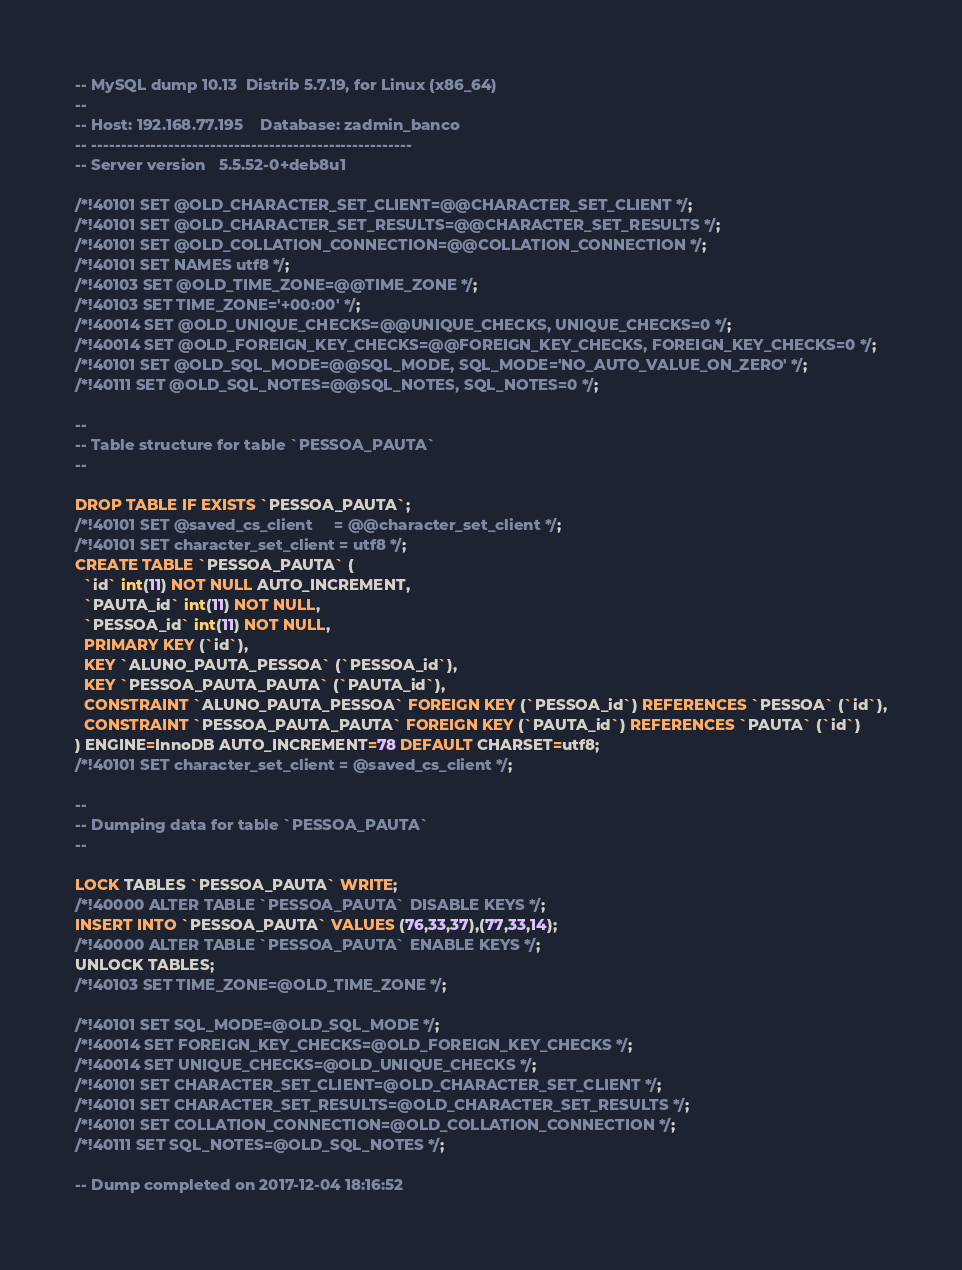Convert code to text. <code><loc_0><loc_0><loc_500><loc_500><_SQL_>-- MySQL dump 10.13  Distrib 5.7.19, for Linux (x86_64)
--
-- Host: 192.168.77.195    Database: zadmin_banco
-- ------------------------------------------------------
-- Server version	5.5.52-0+deb8u1

/*!40101 SET @OLD_CHARACTER_SET_CLIENT=@@CHARACTER_SET_CLIENT */;
/*!40101 SET @OLD_CHARACTER_SET_RESULTS=@@CHARACTER_SET_RESULTS */;
/*!40101 SET @OLD_COLLATION_CONNECTION=@@COLLATION_CONNECTION */;
/*!40101 SET NAMES utf8 */;
/*!40103 SET @OLD_TIME_ZONE=@@TIME_ZONE */;
/*!40103 SET TIME_ZONE='+00:00' */;
/*!40014 SET @OLD_UNIQUE_CHECKS=@@UNIQUE_CHECKS, UNIQUE_CHECKS=0 */;
/*!40014 SET @OLD_FOREIGN_KEY_CHECKS=@@FOREIGN_KEY_CHECKS, FOREIGN_KEY_CHECKS=0 */;
/*!40101 SET @OLD_SQL_MODE=@@SQL_MODE, SQL_MODE='NO_AUTO_VALUE_ON_ZERO' */;
/*!40111 SET @OLD_SQL_NOTES=@@SQL_NOTES, SQL_NOTES=0 */;

--
-- Table structure for table `PESSOA_PAUTA`
--

DROP TABLE IF EXISTS `PESSOA_PAUTA`;
/*!40101 SET @saved_cs_client     = @@character_set_client */;
/*!40101 SET character_set_client = utf8 */;
CREATE TABLE `PESSOA_PAUTA` (
  `id` int(11) NOT NULL AUTO_INCREMENT,
  `PAUTA_id` int(11) NOT NULL,
  `PESSOA_id` int(11) NOT NULL,
  PRIMARY KEY (`id`),
  KEY `ALUNO_PAUTA_PESSOA` (`PESSOA_id`),
  KEY `PESSOA_PAUTA_PAUTA` (`PAUTA_id`),
  CONSTRAINT `ALUNO_PAUTA_PESSOA` FOREIGN KEY (`PESSOA_id`) REFERENCES `PESSOA` (`id`),
  CONSTRAINT `PESSOA_PAUTA_PAUTA` FOREIGN KEY (`PAUTA_id`) REFERENCES `PAUTA` (`id`)
) ENGINE=InnoDB AUTO_INCREMENT=78 DEFAULT CHARSET=utf8;
/*!40101 SET character_set_client = @saved_cs_client */;

--
-- Dumping data for table `PESSOA_PAUTA`
--

LOCK TABLES `PESSOA_PAUTA` WRITE;
/*!40000 ALTER TABLE `PESSOA_PAUTA` DISABLE KEYS */;
INSERT INTO `PESSOA_PAUTA` VALUES (76,33,37),(77,33,14);
/*!40000 ALTER TABLE `PESSOA_PAUTA` ENABLE KEYS */;
UNLOCK TABLES;
/*!40103 SET TIME_ZONE=@OLD_TIME_ZONE */;

/*!40101 SET SQL_MODE=@OLD_SQL_MODE */;
/*!40014 SET FOREIGN_KEY_CHECKS=@OLD_FOREIGN_KEY_CHECKS */;
/*!40014 SET UNIQUE_CHECKS=@OLD_UNIQUE_CHECKS */;
/*!40101 SET CHARACTER_SET_CLIENT=@OLD_CHARACTER_SET_CLIENT */;
/*!40101 SET CHARACTER_SET_RESULTS=@OLD_CHARACTER_SET_RESULTS */;
/*!40101 SET COLLATION_CONNECTION=@OLD_COLLATION_CONNECTION */;
/*!40111 SET SQL_NOTES=@OLD_SQL_NOTES */;

-- Dump completed on 2017-12-04 18:16:52
</code> 